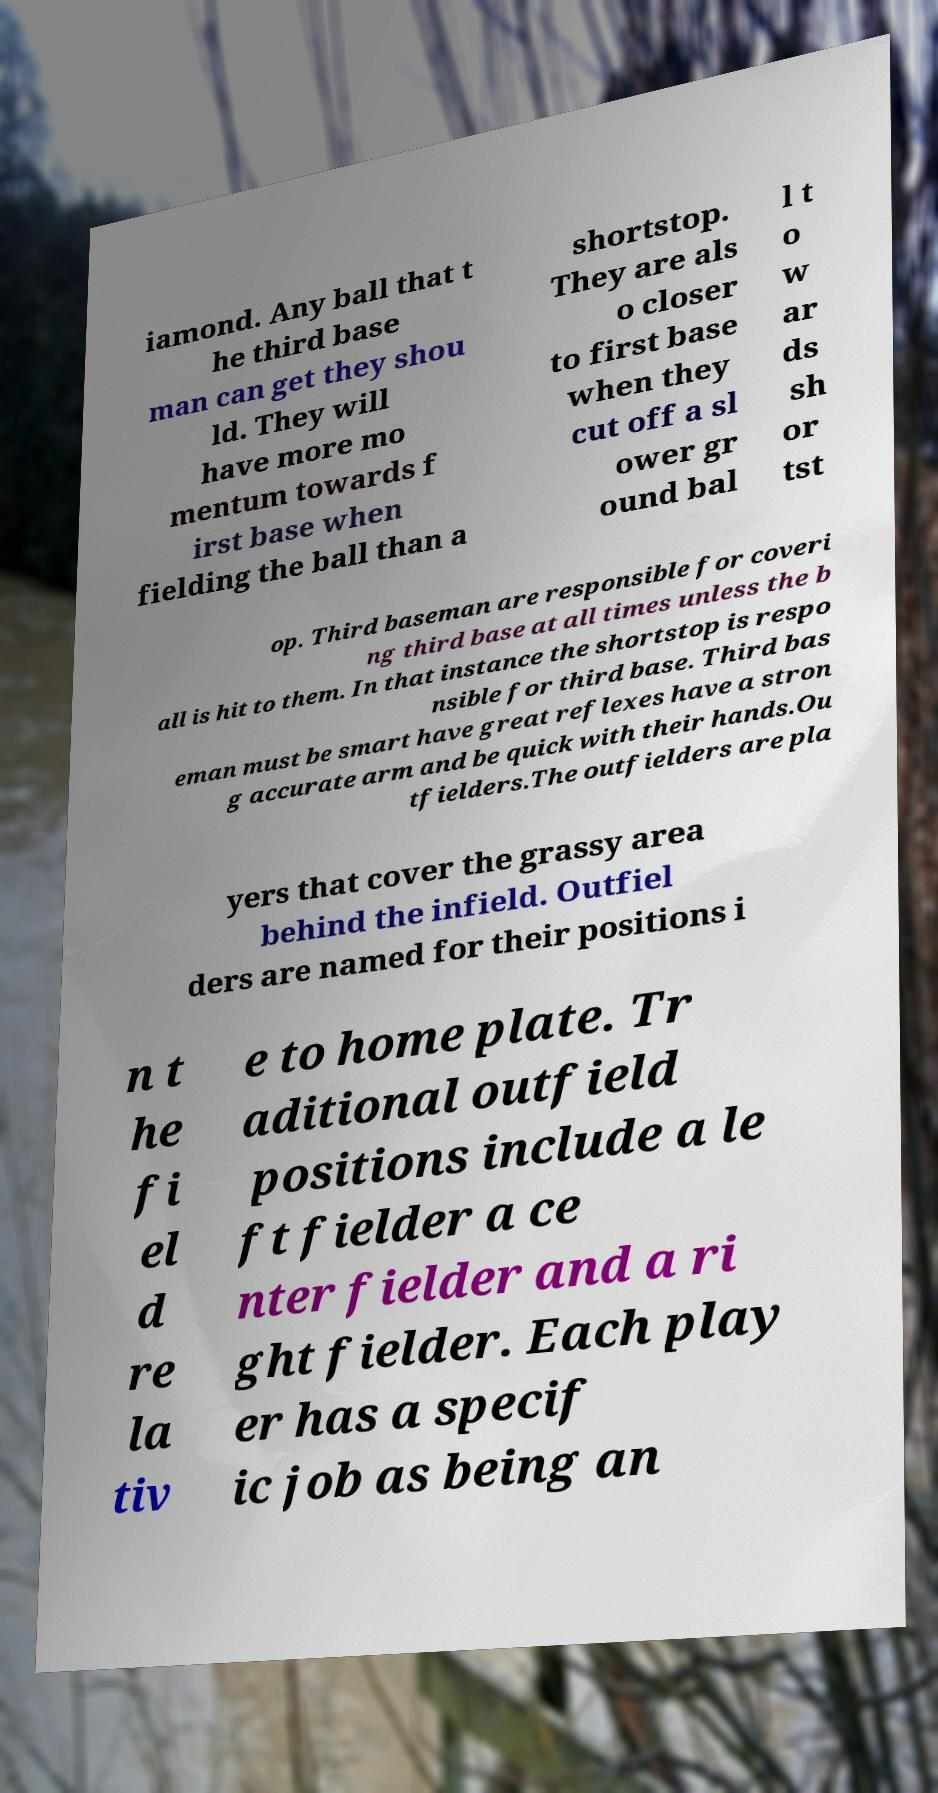I need the written content from this picture converted into text. Can you do that? iamond. Any ball that t he third base man can get they shou ld. They will have more mo mentum towards f irst base when fielding the ball than a shortstop. They are als o closer to first base when they cut off a sl ower gr ound bal l t o w ar ds sh or tst op. Third baseman are responsible for coveri ng third base at all times unless the b all is hit to them. In that instance the shortstop is respo nsible for third base. Third bas eman must be smart have great reflexes have a stron g accurate arm and be quick with their hands.Ou tfielders.The outfielders are pla yers that cover the grassy area behind the infield. Outfiel ders are named for their positions i n t he fi el d re la tiv e to home plate. Tr aditional outfield positions include a le ft fielder a ce nter fielder and a ri ght fielder. Each play er has a specif ic job as being an 